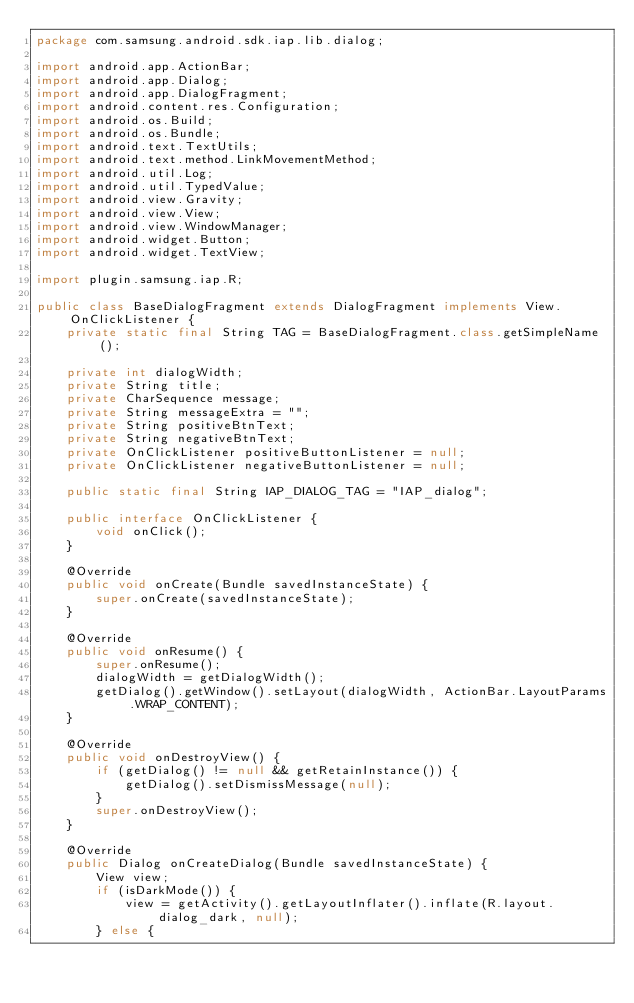<code> <loc_0><loc_0><loc_500><loc_500><_Java_>package com.samsung.android.sdk.iap.lib.dialog;

import android.app.ActionBar;
import android.app.Dialog;
import android.app.DialogFragment;
import android.content.res.Configuration;
import android.os.Build;
import android.os.Bundle;
import android.text.TextUtils;
import android.text.method.LinkMovementMethod;
import android.util.Log;
import android.util.TypedValue;
import android.view.Gravity;
import android.view.View;
import android.view.WindowManager;
import android.widget.Button;
import android.widget.TextView;

import plugin.samsung.iap.R;

public class BaseDialogFragment extends DialogFragment implements View.OnClickListener {
    private static final String TAG = BaseDialogFragment.class.getSimpleName();

    private int dialogWidth;
    private String title;
    private CharSequence message;
    private String messageExtra = "";
    private String positiveBtnText;
    private String negativeBtnText;
    private OnClickListener positiveButtonListener = null;
    private OnClickListener negativeButtonListener = null;

    public static final String IAP_DIALOG_TAG = "IAP_dialog";

    public interface OnClickListener {
        void onClick();
    }

    @Override
    public void onCreate(Bundle savedInstanceState) {
        super.onCreate(savedInstanceState);
    }

    @Override
    public void onResume() {
        super.onResume();
        dialogWidth = getDialogWidth();
        getDialog().getWindow().setLayout(dialogWidth, ActionBar.LayoutParams.WRAP_CONTENT);
    }

    @Override
    public void onDestroyView() {
        if (getDialog() != null && getRetainInstance()) {
            getDialog().setDismissMessage(null);
        }
        super.onDestroyView();
    }

    @Override
    public Dialog onCreateDialog(Bundle savedInstanceState) {
        View view;
        if (isDarkMode()) {
            view = getActivity().getLayoutInflater().inflate(R.layout.dialog_dark, null);
        } else {</code> 